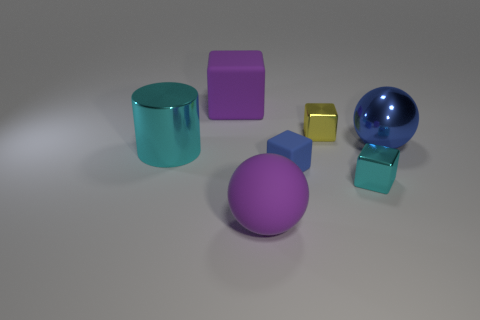Subtract all big blocks. How many blocks are left? 3 Subtract all blue blocks. How many blocks are left? 3 Subtract all blocks. How many objects are left? 3 Add 2 tiny yellow cubes. How many objects exist? 9 Subtract all large rubber objects. Subtract all large blocks. How many objects are left? 4 Add 1 blue metallic spheres. How many blue metallic spheres are left? 2 Add 3 large blocks. How many large blocks exist? 4 Subtract 0 green cubes. How many objects are left? 7 Subtract all purple cubes. Subtract all green balls. How many cubes are left? 3 